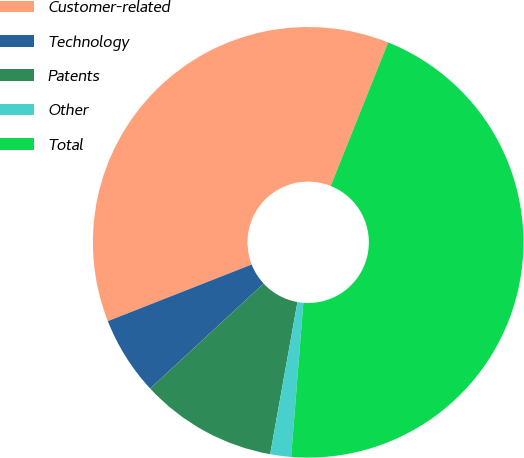<chart> <loc_0><loc_0><loc_500><loc_500><pie_chart><fcel>Customer-related<fcel>Technology<fcel>Patents<fcel>Other<fcel>Total<nl><fcel>37.02%<fcel>5.92%<fcel>10.29%<fcel>1.56%<fcel>45.2%<nl></chart> 